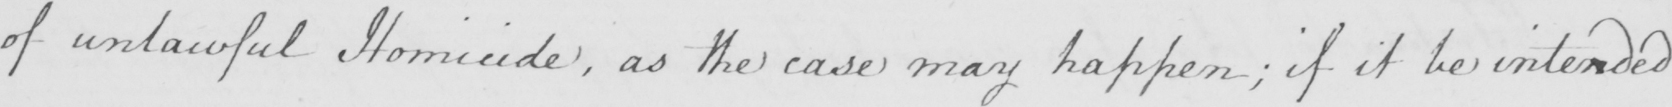What text is written in this handwritten line? of unlawful Homicide , as the case may happen ; if it be intended 